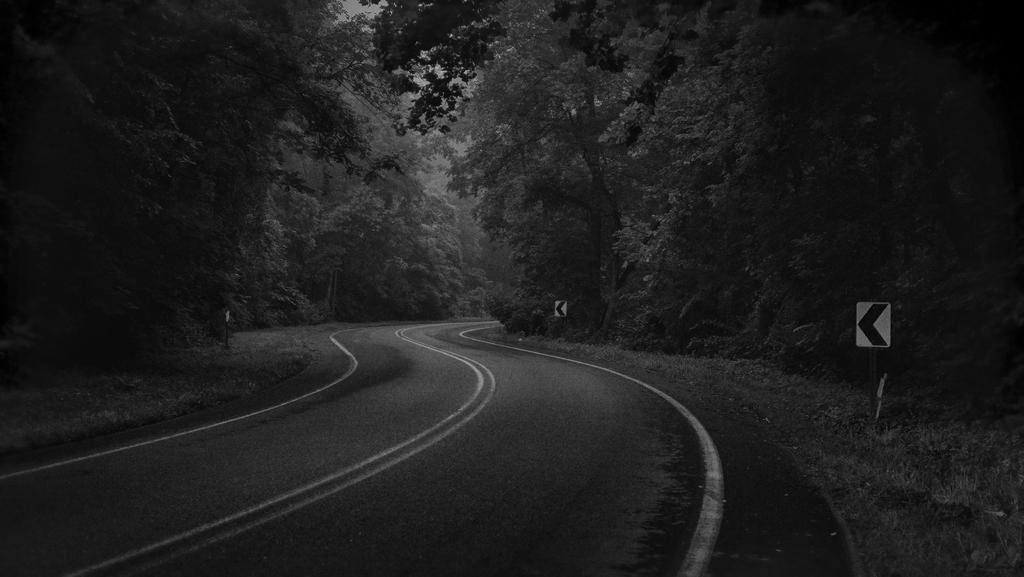Can you describe this image briefly? This is a black and white image. In this image we can see trees, sign boards and road. 